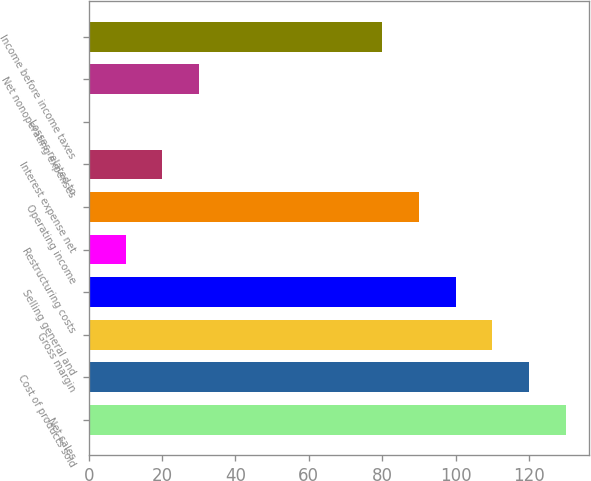Convert chart to OTSL. <chart><loc_0><loc_0><loc_500><loc_500><bar_chart><fcel>Net sales<fcel>Cost of products sold<fcel>Gross margin<fcel>Selling general and<fcel>Restructuring costs<fcel>Operating income<fcel>Interest expense net<fcel>Losses related to<fcel>Net nonoperating expenses<fcel>Income before income taxes<nl><fcel>129.97<fcel>119.98<fcel>109.99<fcel>100<fcel>10.09<fcel>90.01<fcel>20.08<fcel>0.1<fcel>30.07<fcel>80.02<nl></chart> 